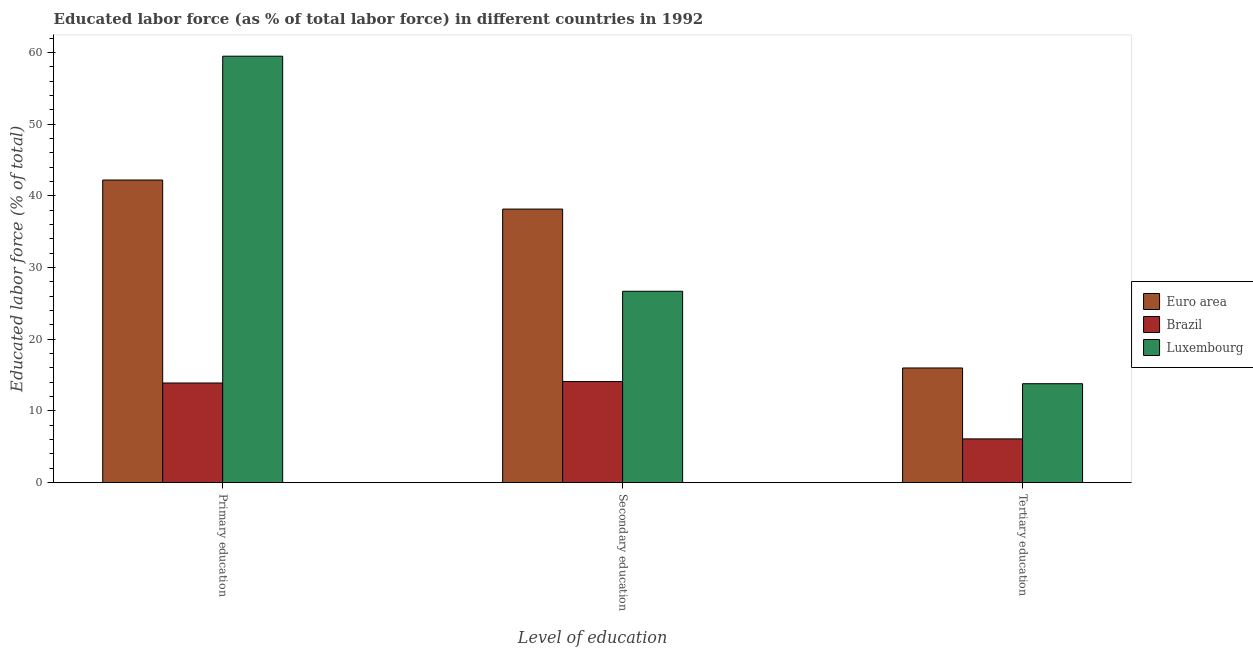How many different coloured bars are there?
Offer a terse response. 3. How many groups of bars are there?
Offer a very short reply. 3. Are the number of bars per tick equal to the number of legend labels?
Make the answer very short. Yes. Are the number of bars on each tick of the X-axis equal?
Provide a succinct answer. Yes. How many bars are there on the 1st tick from the left?
Your answer should be very brief. 3. How many bars are there on the 2nd tick from the right?
Offer a terse response. 3. What is the label of the 2nd group of bars from the left?
Provide a short and direct response. Secondary education. What is the percentage of labor force who received primary education in Luxembourg?
Provide a short and direct response. 59.5. Across all countries, what is the maximum percentage of labor force who received tertiary education?
Ensure brevity in your answer.  16. Across all countries, what is the minimum percentage of labor force who received secondary education?
Your answer should be very brief. 14.1. What is the total percentage of labor force who received tertiary education in the graph?
Provide a short and direct response. 35.9. What is the difference between the percentage of labor force who received tertiary education in Brazil and that in Luxembourg?
Ensure brevity in your answer.  -7.7. What is the difference between the percentage of labor force who received secondary education in Euro area and the percentage of labor force who received tertiary education in Luxembourg?
Give a very brief answer. 24.37. What is the average percentage of labor force who received tertiary education per country?
Provide a short and direct response. 11.97. What is the difference between the percentage of labor force who received primary education and percentage of labor force who received tertiary education in Luxembourg?
Your answer should be very brief. 45.7. In how many countries, is the percentage of labor force who received secondary education greater than 26 %?
Provide a succinct answer. 2. What is the ratio of the percentage of labor force who received tertiary education in Euro area to that in Luxembourg?
Make the answer very short. 1.16. Is the percentage of labor force who received primary education in Brazil less than that in Luxembourg?
Your answer should be very brief. Yes. Is the difference between the percentage of labor force who received primary education in Euro area and Brazil greater than the difference between the percentage of labor force who received secondary education in Euro area and Brazil?
Your answer should be compact. Yes. What is the difference between the highest and the second highest percentage of labor force who received primary education?
Your answer should be very brief. 17.28. What is the difference between the highest and the lowest percentage of labor force who received secondary education?
Make the answer very short. 24.07. What does the 2nd bar from the left in Tertiary education represents?
Keep it short and to the point. Brazil. Is it the case that in every country, the sum of the percentage of labor force who received primary education and percentage of labor force who received secondary education is greater than the percentage of labor force who received tertiary education?
Ensure brevity in your answer.  Yes. How many bars are there?
Provide a succinct answer. 9. Are all the bars in the graph horizontal?
Provide a succinct answer. No. How many countries are there in the graph?
Your answer should be very brief. 3. Are the values on the major ticks of Y-axis written in scientific E-notation?
Keep it short and to the point. No. Does the graph contain grids?
Provide a short and direct response. No. How are the legend labels stacked?
Ensure brevity in your answer.  Vertical. What is the title of the graph?
Offer a terse response. Educated labor force (as % of total labor force) in different countries in 1992. Does "Malawi" appear as one of the legend labels in the graph?
Give a very brief answer. No. What is the label or title of the X-axis?
Ensure brevity in your answer.  Level of education. What is the label or title of the Y-axis?
Keep it short and to the point. Educated labor force (% of total). What is the Educated labor force (% of total) in Euro area in Primary education?
Your answer should be very brief. 42.22. What is the Educated labor force (% of total) of Brazil in Primary education?
Provide a short and direct response. 13.9. What is the Educated labor force (% of total) in Luxembourg in Primary education?
Provide a short and direct response. 59.5. What is the Educated labor force (% of total) of Euro area in Secondary education?
Provide a short and direct response. 38.17. What is the Educated labor force (% of total) in Brazil in Secondary education?
Offer a terse response. 14.1. What is the Educated labor force (% of total) in Luxembourg in Secondary education?
Provide a succinct answer. 26.7. What is the Educated labor force (% of total) in Euro area in Tertiary education?
Provide a short and direct response. 16. What is the Educated labor force (% of total) in Brazil in Tertiary education?
Keep it short and to the point. 6.1. What is the Educated labor force (% of total) of Luxembourg in Tertiary education?
Provide a short and direct response. 13.8. Across all Level of education, what is the maximum Educated labor force (% of total) of Euro area?
Offer a very short reply. 42.22. Across all Level of education, what is the maximum Educated labor force (% of total) in Brazil?
Keep it short and to the point. 14.1. Across all Level of education, what is the maximum Educated labor force (% of total) in Luxembourg?
Your answer should be very brief. 59.5. Across all Level of education, what is the minimum Educated labor force (% of total) in Euro area?
Ensure brevity in your answer.  16. Across all Level of education, what is the minimum Educated labor force (% of total) in Brazil?
Offer a very short reply. 6.1. Across all Level of education, what is the minimum Educated labor force (% of total) of Luxembourg?
Offer a very short reply. 13.8. What is the total Educated labor force (% of total) in Euro area in the graph?
Provide a succinct answer. 96.39. What is the total Educated labor force (% of total) of Brazil in the graph?
Provide a succinct answer. 34.1. What is the difference between the Educated labor force (% of total) in Euro area in Primary education and that in Secondary education?
Offer a very short reply. 4.05. What is the difference between the Educated labor force (% of total) in Luxembourg in Primary education and that in Secondary education?
Your answer should be compact. 32.8. What is the difference between the Educated labor force (% of total) in Euro area in Primary education and that in Tertiary education?
Offer a terse response. 26.23. What is the difference between the Educated labor force (% of total) in Luxembourg in Primary education and that in Tertiary education?
Your response must be concise. 45.7. What is the difference between the Educated labor force (% of total) in Euro area in Secondary education and that in Tertiary education?
Offer a very short reply. 22.17. What is the difference between the Educated labor force (% of total) of Brazil in Secondary education and that in Tertiary education?
Give a very brief answer. 8. What is the difference between the Educated labor force (% of total) in Luxembourg in Secondary education and that in Tertiary education?
Provide a short and direct response. 12.9. What is the difference between the Educated labor force (% of total) of Euro area in Primary education and the Educated labor force (% of total) of Brazil in Secondary education?
Ensure brevity in your answer.  28.12. What is the difference between the Educated labor force (% of total) in Euro area in Primary education and the Educated labor force (% of total) in Luxembourg in Secondary education?
Give a very brief answer. 15.52. What is the difference between the Educated labor force (% of total) of Brazil in Primary education and the Educated labor force (% of total) of Luxembourg in Secondary education?
Ensure brevity in your answer.  -12.8. What is the difference between the Educated labor force (% of total) in Euro area in Primary education and the Educated labor force (% of total) in Brazil in Tertiary education?
Provide a succinct answer. 36.12. What is the difference between the Educated labor force (% of total) in Euro area in Primary education and the Educated labor force (% of total) in Luxembourg in Tertiary education?
Give a very brief answer. 28.42. What is the difference between the Educated labor force (% of total) in Brazil in Primary education and the Educated labor force (% of total) in Luxembourg in Tertiary education?
Make the answer very short. 0.1. What is the difference between the Educated labor force (% of total) of Euro area in Secondary education and the Educated labor force (% of total) of Brazil in Tertiary education?
Give a very brief answer. 32.07. What is the difference between the Educated labor force (% of total) of Euro area in Secondary education and the Educated labor force (% of total) of Luxembourg in Tertiary education?
Your answer should be very brief. 24.37. What is the difference between the Educated labor force (% of total) of Brazil in Secondary education and the Educated labor force (% of total) of Luxembourg in Tertiary education?
Provide a succinct answer. 0.3. What is the average Educated labor force (% of total) of Euro area per Level of education?
Keep it short and to the point. 32.13. What is the average Educated labor force (% of total) in Brazil per Level of education?
Your answer should be very brief. 11.37. What is the average Educated labor force (% of total) in Luxembourg per Level of education?
Provide a short and direct response. 33.33. What is the difference between the Educated labor force (% of total) of Euro area and Educated labor force (% of total) of Brazil in Primary education?
Your answer should be very brief. 28.32. What is the difference between the Educated labor force (% of total) of Euro area and Educated labor force (% of total) of Luxembourg in Primary education?
Make the answer very short. -17.28. What is the difference between the Educated labor force (% of total) of Brazil and Educated labor force (% of total) of Luxembourg in Primary education?
Make the answer very short. -45.6. What is the difference between the Educated labor force (% of total) of Euro area and Educated labor force (% of total) of Brazil in Secondary education?
Provide a succinct answer. 24.07. What is the difference between the Educated labor force (% of total) in Euro area and Educated labor force (% of total) in Luxembourg in Secondary education?
Make the answer very short. 11.47. What is the difference between the Educated labor force (% of total) in Euro area and Educated labor force (% of total) in Brazil in Tertiary education?
Your answer should be compact. 9.9. What is the difference between the Educated labor force (% of total) in Euro area and Educated labor force (% of total) in Luxembourg in Tertiary education?
Your answer should be compact. 2.2. What is the difference between the Educated labor force (% of total) in Brazil and Educated labor force (% of total) in Luxembourg in Tertiary education?
Keep it short and to the point. -7.7. What is the ratio of the Educated labor force (% of total) in Euro area in Primary education to that in Secondary education?
Your response must be concise. 1.11. What is the ratio of the Educated labor force (% of total) of Brazil in Primary education to that in Secondary education?
Ensure brevity in your answer.  0.99. What is the ratio of the Educated labor force (% of total) in Luxembourg in Primary education to that in Secondary education?
Provide a short and direct response. 2.23. What is the ratio of the Educated labor force (% of total) in Euro area in Primary education to that in Tertiary education?
Keep it short and to the point. 2.64. What is the ratio of the Educated labor force (% of total) in Brazil in Primary education to that in Tertiary education?
Keep it short and to the point. 2.28. What is the ratio of the Educated labor force (% of total) in Luxembourg in Primary education to that in Tertiary education?
Keep it short and to the point. 4.31. What is the ratio of the Educated labor force (% of total) of Euro area in Secondary education to that in Tertiary education?
Your answer should be compact. 2.39. What is the ratio of the Educated labor force (% of total) in Brazil in Secondary education to that in Tertiary education?
Offer a terse response. 2.31. What is the ratio of the Educated labor force (% of total) in Luxembourg in Secondary education to that in Tertiary education?
Keep it short and to the point. 1.93. What is the difference between the highest and the second highest Educated labor force (% of total) in Euro area?
Your answer should be very brief. 4.05. What is the difference between the highest and the second highest Educated labor force (% of total) of Brazil?
Your answer should be very brief. 0.2. What is the difference between the highest and the second highest Educated labor force (% of total) in Luxembourg?
Ensure brevity in your answer.  32.8. What is the difference between the highest and the lowest Educated labor force (% of total) of Euro area?
Offer a very short reply. 26.23. What is the difference between the highest and the lowest Educated labor force (% of total) of Brazil?
Your answer should be compact. 8. What is the difference between the highest and the lowest Educated labor force (% of total) in Luxembourg?
Make the answer very short. 45.7. 